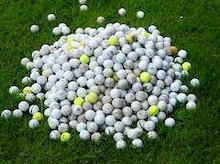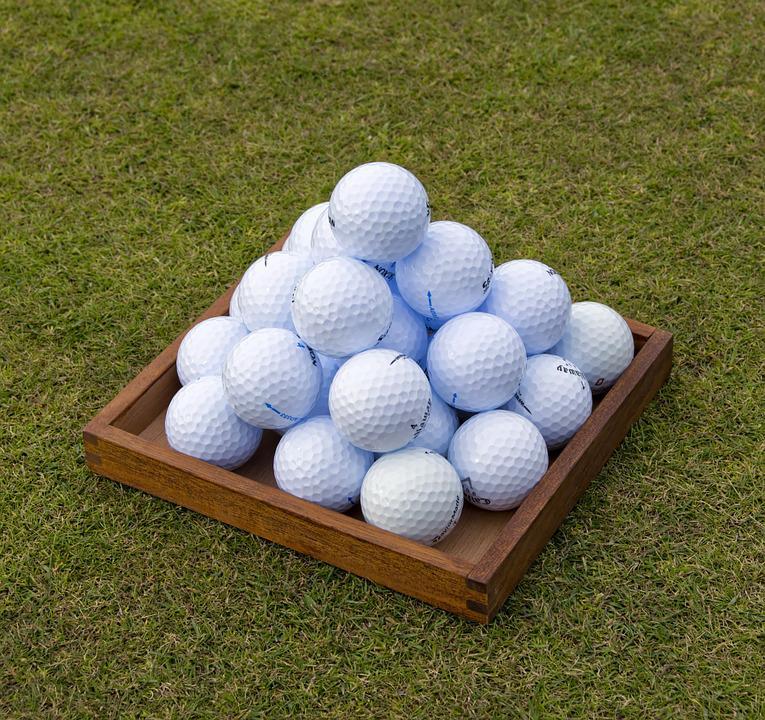The first image is the image on the left, the second image is the image on the right. Assess this claim about the two images: "An image shows golf balls in some type of square shape, on a grass type background.". Correct or not? Answer yes or no. Yes. The first image is the image on the left, the second image is the image on the right. Assess this claim about the two images: "There is one golf ball sitting on top of other balls in the image on the right.". Correct or not? Answer yes or no. Yes. The first image is the image on the left, the second image is the image on the right. Examine the images to the left and right. Is the description "Both images show golf balls on a grass-type background." accurate? Answer yes or no. Yes. The first image is the image on the left, the second image is the image on the right. Assess this claim about the two images: "At least one of the images do not contain grass.". Correct or not? Answer yes or no. No. 